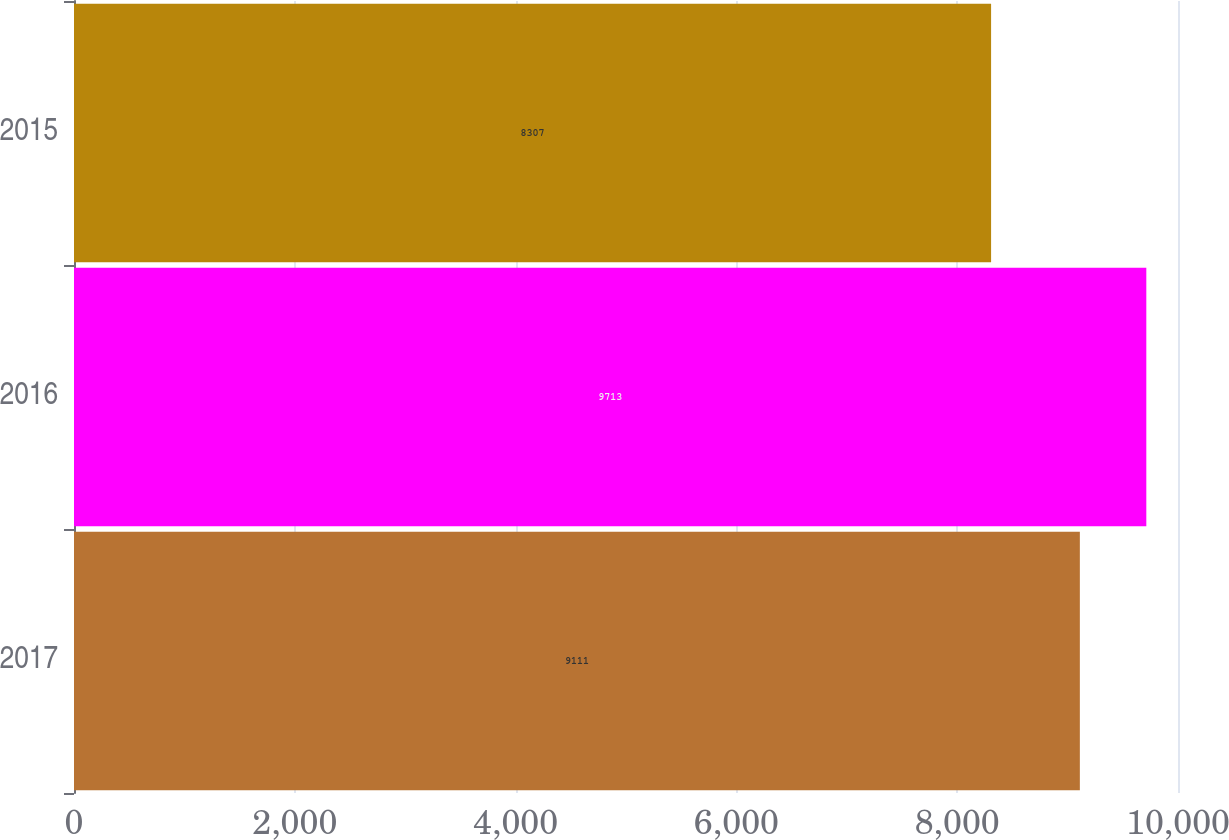Convert chart. <chart><loc_0><loc_0><loc_500><loc_500><bar_chart><fcel>2017<fcel>2016<fcel>2015<nl><fcel>9111<fcel>9713<fcel>8307<nl></chart> 